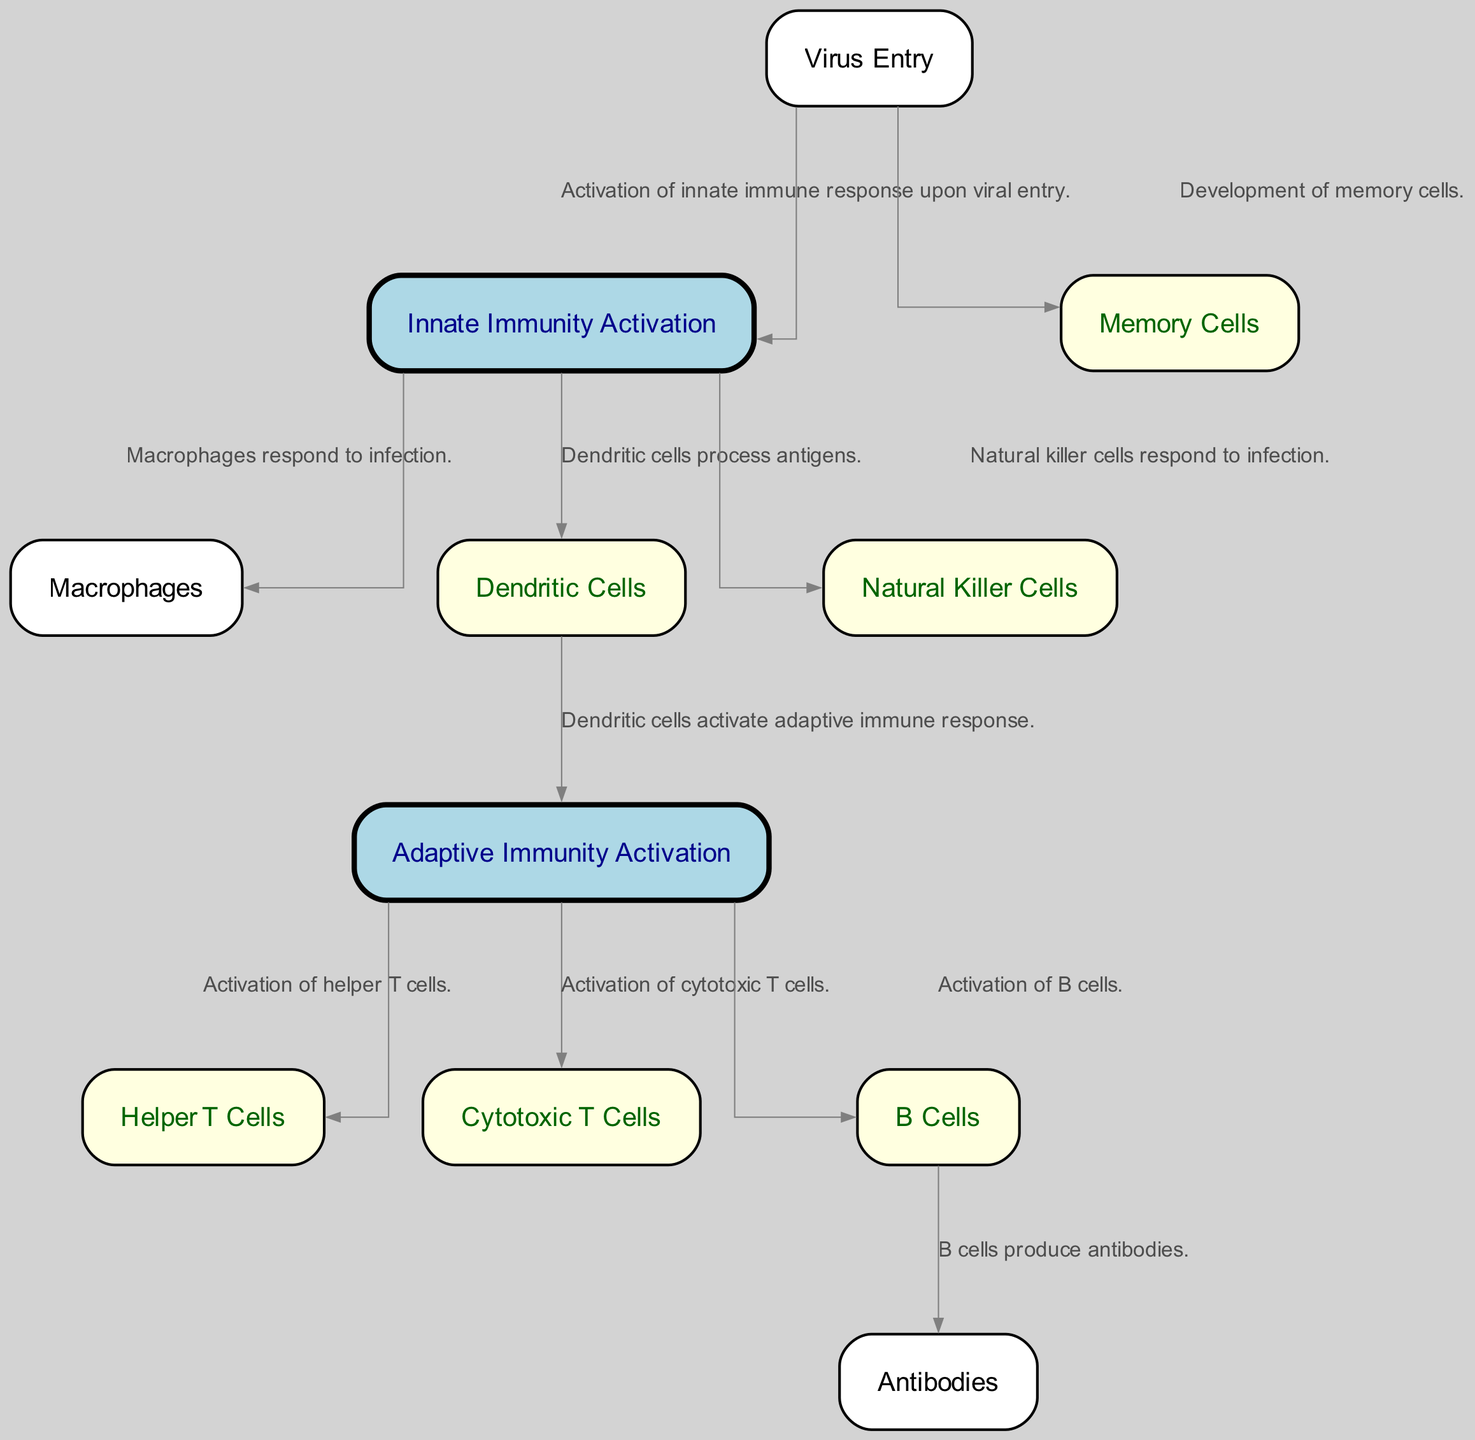What is the first step in the immune response? The diagram indicates that the first step in the immune response is "Virus Entry," which is where the virus enters the human body and begins to infect host cells.
Answer: Virus Entry How many types of immune cells are shown in the diagram? Upon reviewing the diagram, we can count the different immune cells represented: Macrophages, Dendritic Cells, Natural Killer Cells, Helper T Cells, Cytotoxic T Cells, and B Cells, totaling six types of immune cells.
Answer: Six What do B Cells produce? According to the diagram, B Cells produce "Antibodies," which are crucial for binding to and neutralizing viruses.
Answer: Antibodies What role do Dendritic Cells play in the immune response? Dendritic Cells are shown in the diagram to "Capture antigens and present them to T cells in lymph nodes," indicating their critical role in bridging innate and adaptive immunity.
Answer: Capture antigens and present them to T cells Which cells are activated by Helper T Cells? The diagram indicates several cells activated by Helper T Cells: including Cytotoxic T Cells and B Cells; thus, Helper T Cells play a pivotal role in enhancing the immune response.
Answer: Cytotoxic T Cells and B Cells How do Natural Killer Cells respond to infection? The diagram states that Natural Killer Cells "Destroy infected cells by inducing apoptosis," which shows their function in directly eliminating infected cells.
Answer: Destroy infected cells by inducing apoptosis What is the function of Memory Cells in the immune system? Memory Cells are indicated in the diagram to "Provide long-term immunity by remembering past infections," illustrating their role in maintaining immunological memory.
Answer: Provide long-term immunity by remembering past infections Which process activates the Adaptive Immunity? The diagram shows that the activation of Adaptive Immunity occurs following the "Dendritic Cells" processing and acting on the "Innate Immunity Activation," indicating the transition between the two forms of immunity.
Answer: Dendritic Cells What is the relationship between Virus Entry and Memory Cells? The diagram connects "Virus Entry" directly to the development of "Memory Cells," signifying that memory cells are generated as part of the immune response to a virus entry.
Answer: Development of memory cells 